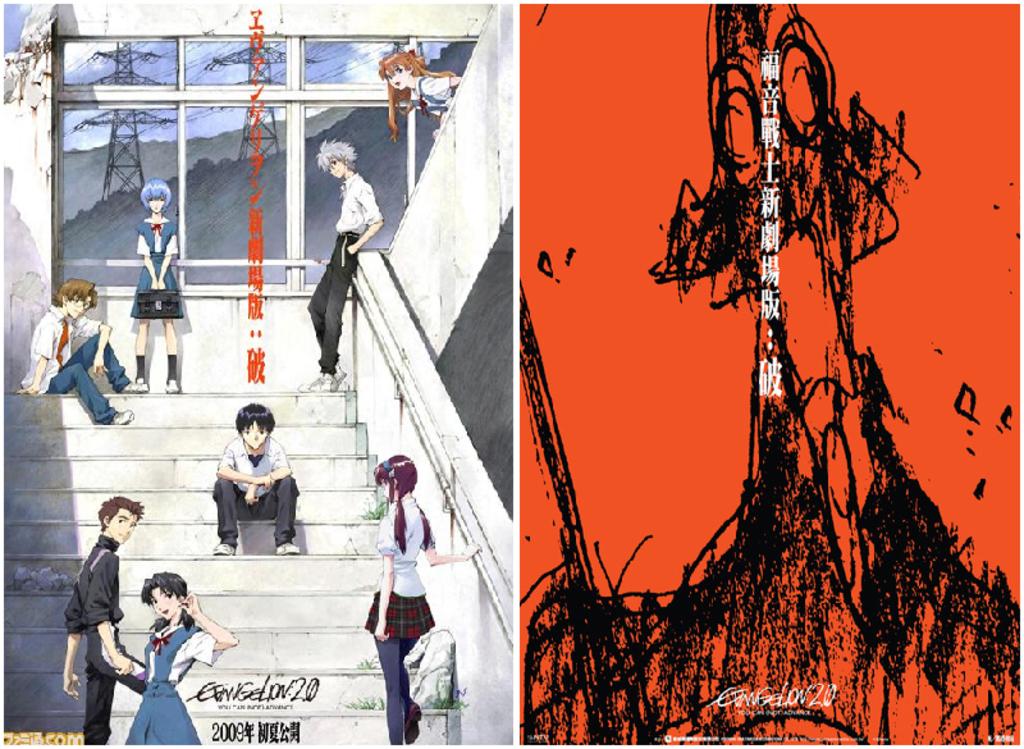What year is on the bottom of the left hand poster?
Give a very brief answer. 2009. 